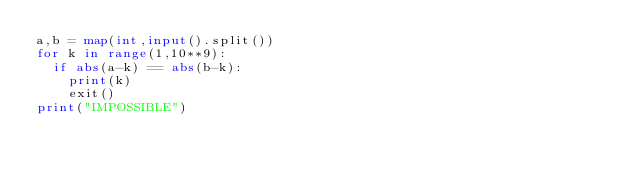Convert code to text. <code><loc_0><loc_0><loc_500><loc_500><_Python_>a,b = map(int,input().split())
for k in range(1,10**9):
  if abs(a-k) == abs(b-k):
    print(k)
    exit()
print("IMPOSSIBLE")</code> 